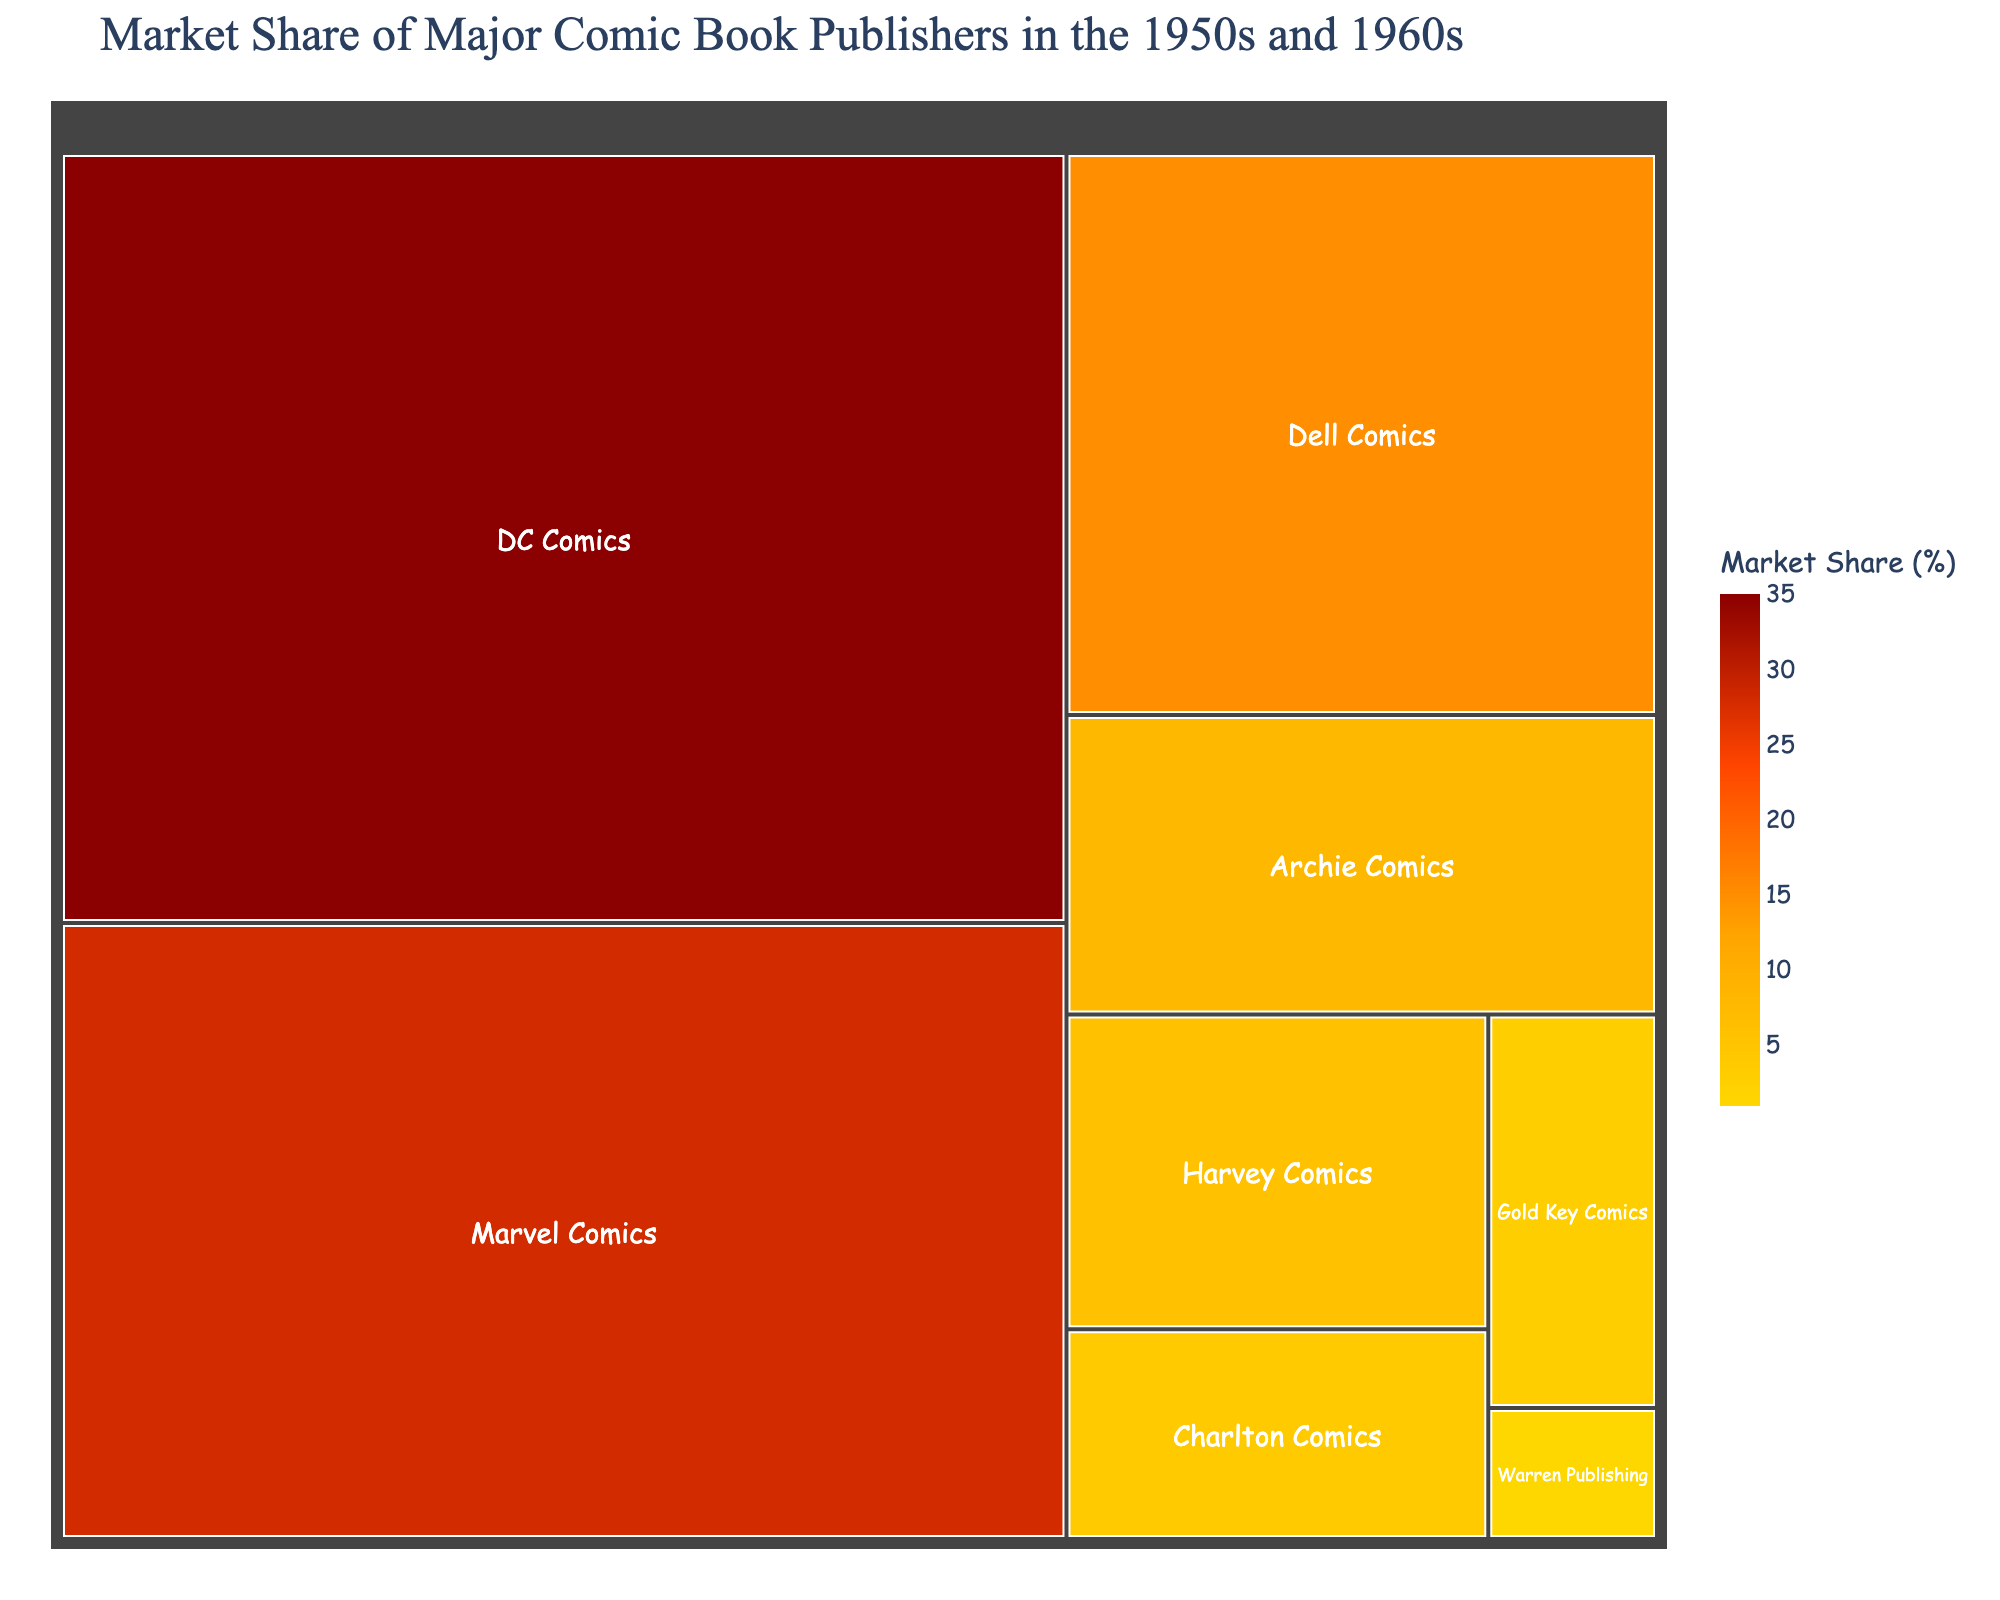What is the title of the figure? The title is located at the top of the treemap and provides a summary of what the figure represents.
Answer: Market Share of Major Comic Book Publishers in the 1950s and 1960s Which publisher has the largest market share? The largest segment in the treemap is the one corresponding to the publisher with the largest market share.
Answer: DC Comics How much market share does Marvel Comics have? Locate the segment labeled Marvel Comics and read the market share value from the hover info or segment size.
Answer: 28% What is the combined market share of Dell Comics and Archie Comics? Sum the market shares of Dell Comics (15%) and Archie Comics (8%).
Answer: 23% Which publisher has the smallest market share? The smallest segment in the treemap represents the publisher with the smallest market share.
Answer: Warren Publishing How many publishers have a market share greater than 10%? Identify and count the segments with market shares greater than 10% (DC Comics, Marvel Comics, and Dell Comics).
Answer: 3 What is the difference in market share between DC Comics and Charlton Comics? Subtract the market share of Charlton Comics (4%) from DC Comics (35%).
Answer: 31% Are there any publishers with exactly 6% market share? Look for segments with a market share value of 6%.
Answer: Yes, Harvey Comics Which has a higher market share, Gold Key Comics or Archie Comics? Compare the market share values, 3% for Gold Key Comics and 8% for Archie Comics.
Answer: Archie Comics What is the color range of the treemap used to represent different market shares? Identify the colors used in different segments, ranging from lighter to darker shades.
Answer: Yellow to dark red 